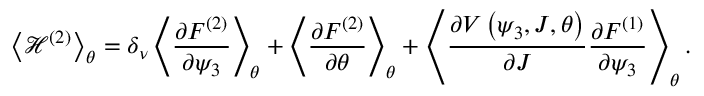<formula> <loc_0><loc_0><loc_500><loc_500>\left < { \mathcal { H } ^ { \left ( 2 \right ) } } \right > _ { \theta } = \delta _ { \nu } \left < { \frac { \partial F ^ { ( 2 ) } } { \partial \psi _ { 3 } } } \right > _ { \theta } + \left < { \frac { \partial F ^ { ( 2 ) } } { \partial \theta } } \right > _ { \theta } + \left < { \frac { \partial V \left ( \psi _ { 3 } , J , \theta \right ) } { \partial J } \frac { \partial F ^ { ( 1 ) } } { \partial \psi _ { 3 } } } \right > _ { \theta } .</formula> 